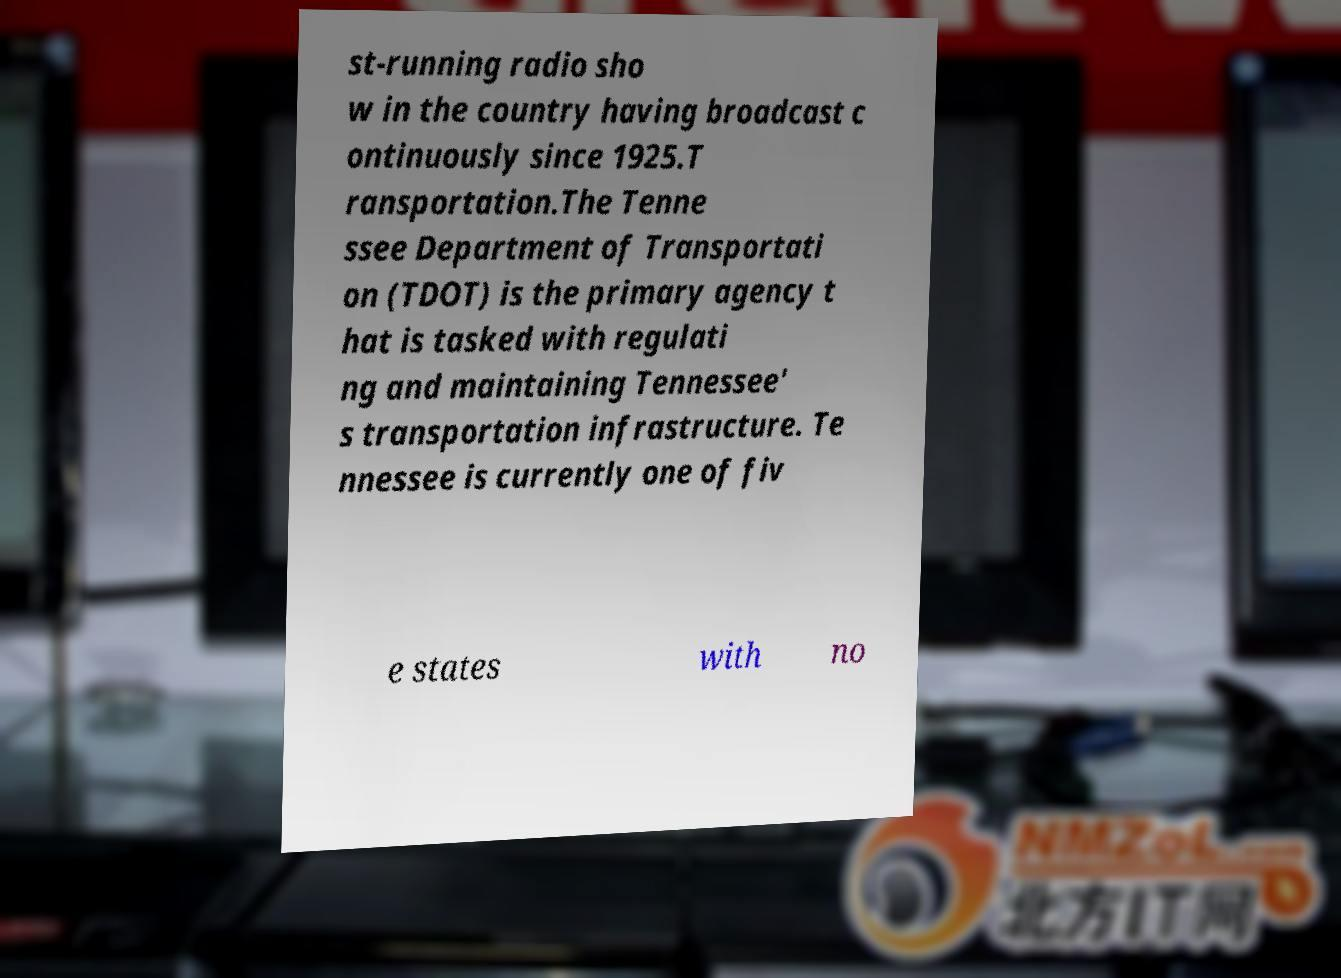Can you accurately transcribe the text from the provided image for me? st-running radio sho w in the country having broadcast c ontinuously since 1925.T ransportation.The Tenne ssee Department of Transportati on (TDOT) is the primary agency t hat is tasked with regulati ng and maintaining Tennessee' s transportation infrastructure. Te nnessee is currently one of fiv e states with no 